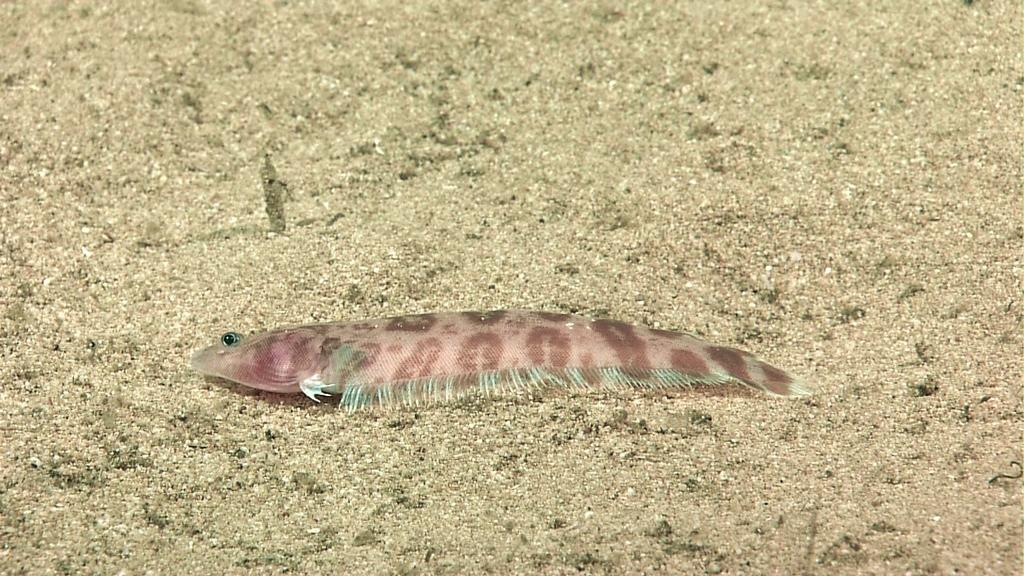What is the main subject in the center of the image? There is a worm in the center of the image. What type of terrain is visible at the bottom of the image? There is sand at the bottom of the image. Where is the rabbit hiding in the image? There is no rabbit present in the image. Can you touch the worm in the image? The image is a visual representation, and you cannot physically touch or interact with the worm in the image. 